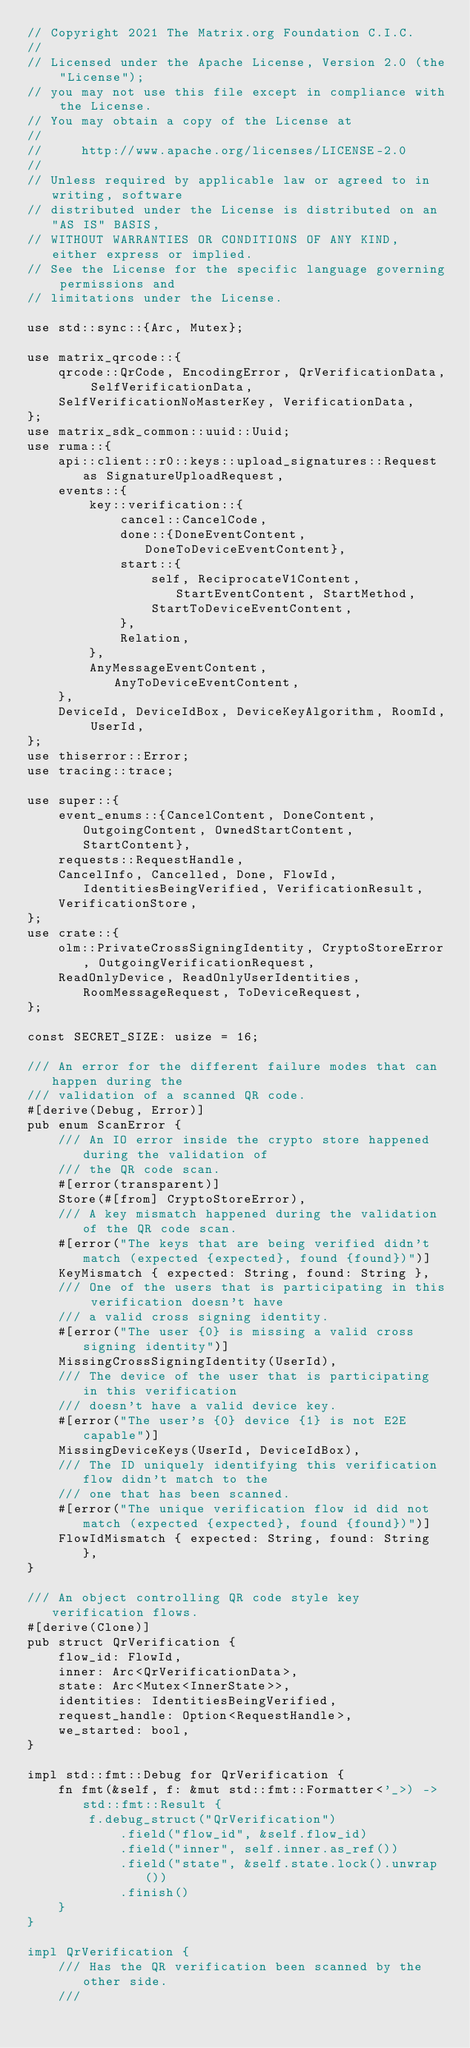Convert code to text. <code><loc_0><loc_0><loc_500><loc_500><_Rust_>// Copyright 2021 The Matrix.org Foundation C.I.C.
//
// Licensed under the Apache License, Version 2.0 (the "License");
// you may not use this file except in compliance with the License.
// You may obtain a copy of the License at
//
//     http://www.apache.org/licenses/LICENSE-2.0
//
// Unless required by applicable law or agreed to in writing, software
// distributed under the License is distributed on an "AS IS" BASIS,
// WITHOUT WARRANTIES OR CONDITIONS OF ANY KIND, either express or implied.
// See the License for the specific language governing permissions and
// limitations under the License.

use std::sync::{Arc, Mutex};

use matrix_qrcode::{
    qrcode::QrCode, EncodingError, QrVerificationData, SelfVerificationData,
    SelfVerificationNoMasterKey, VerificationData,
};
use matrix_sdk_common::uuid::Uuid;
use ruma::{
    api::client::r0::keys::upload_signatures::Request as SignatureUploadRequest,
    events::{
        key::verification::{
            cancel::CancelCode,
            done::{DoneEventContent, DoneToDeviceEventContent},
            start::{
                self, ReciprocateV1Content, StartEventContent, StartMethod,
                StartToDeviceEventContent,
            },
            Relation,
        },
        AnyMessageEventContent, AnyToDeviceEventContent,
    },
    DeviceId, DeviceIdBox, DeviceKeyAlgorithm, RoomId, UserId,
};
use thiserror::Error;
use tracing::trace;

use super::{
    event_enums::{CancelContent, DoneContent, OutgoingContent, OwnedStartContent, StartContent},
    requests::RequestHandle,
    CancelInfo, Cancelled, Done, FlowId, IdentitiesBeingVerified, VerificationResult,
    VerificationStore,
};
use crate::{
    olm::PrivateCrossSigningIdentity, CryptoStoreError, OutgoingVerificationRequest,
    ReadOnlyDevice, ReadOnlyUserIdentities, RoomMessageRequest, ToDeviceRequest,
};

const SECRET_SIZE: usize = 16;

/// An error for the different failure modes that can happen during the
/// validation of a scanned QR code.
#[derive(Debug, Error)]
pub enum ScanError {
    /// An IO error inside the crypto store happened during the validation of
    /// the QR code scan.
    #[error(transparent)]
    Store(#[from] CryptoStoreError),
    /// A key mismatch happened during the validation of the QR code scan.
    #[error("The keys that are being verified didn't match (expected {expected}, found {found})")]
    KeyMismatch { expected: String, found: String },
    /// One of the users that is participating in this verification doesn't have
    /// a valid cross signing identity.
    #[error("The user {0} is missing a valid cross signing identity")]
    MissingCrossSigningIdentity(UserId),
    /// The device of the user that is participating in this verification
    /// doesn't have a valid device key.
    #[error("The user's {0} device {1} is not E2E capable")]
    MissingDeviceKeys(UserId, DeviceIdBox),
    /// The ID uniquely identifying this verification flow didn't match to the
    /// one that has been scanned.
    #[error("The unique verification flow id did not match (expected {expected}, found {found})")]
    FlowIdMismatch { expected: String, found: String },
}

/// An object controlling QR code style key verification flows.
#[derive(Clone)]
pub struct QrVerification {
    flow_id: FlowId,
    inner: Arc<QrVerificationData>,
    state: Arc<Mutex<InnerState>>,
    identities: IdentitiesBeingVerified,
    request_handle: Option<RequestHandle>,
    we_started: bool,
}

impl std::fmt::Debug for QrVerification {
    fn fmt(&self, f: &mut std::fmt::Formatter<'_>) -> std::fmt::Result {
        f.debug_struct("QrVerification")
            .field("flow_id", &self.flow_id)
            .field("inner", self.inner.as_ref())
            .field("state", &self.state.lock().unwrap())
            .finish()
    }
}

impl QrVerification {
    /// Has the QR verification been scanned by the other side.
    ///</code> 